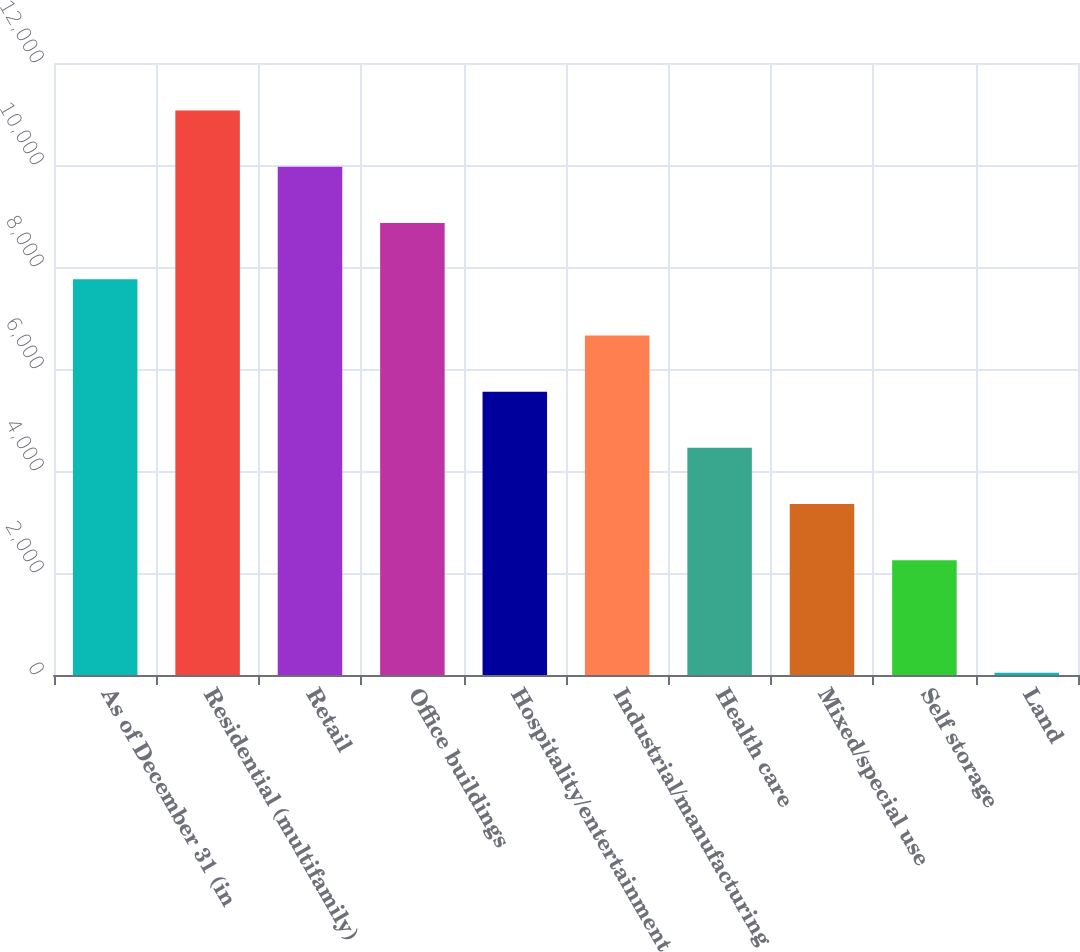Convert chart. <chart><loc_0><loc_0><loc_500><loc_500><bar_chart><fcel>As of December 31 (in<fcel>Residential (multifamily)<fcel>Retail<fcel>Office buildings<fcel>Hospitality/entertainment<fcel>Industrial/manufacturing<fcel>Health care<fcel>Mixed/special use<fcel>Self storage<fcel>Land<nl><fcel>7761.29<fcel>11068.7<fcel>9966.23<fcel>8863.76<fcel>5556.35<fcel>6658.82<fcel>4453.88<fcel>3351.41<fcel>2248.94<fcel>44<nl></chart> 